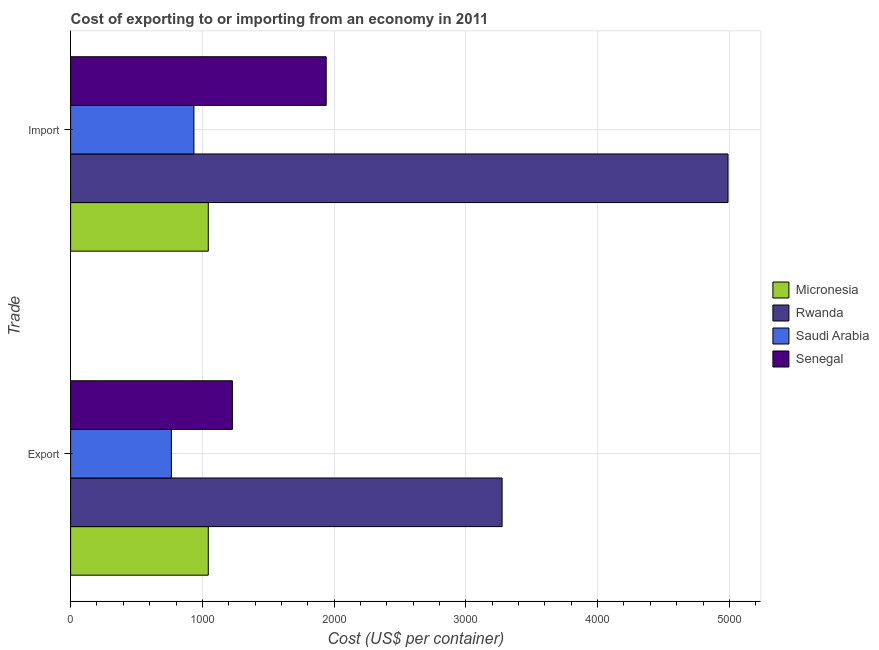How many bars are there on the 1st tick from the bottom?
Your answer should be very brief. 4. What is the label of the 2nd group of bars from the top?
Your answer should be very brief. Export. What is the export cost in Saudi Arabia?
Your response must be concise. 765. Across all countries, what is the maximum export cost?
Your answer should be compact. 3275. Across all countries, what is the minimum export cost?
Provide a short and direct response. 765. In which country was the export cost maximum?
Keep it short and to the point. Rwanda. In which country was the export cost minimum?
Provide a succinct answer. Saudi Arabia. What is the total import cost in the graph?
Make the answer very short. 8911. What is the difference between the import cost in Saudi Arabia and that in Micronesia?
Make the answer very short. -109. What is the difference between the export cost in Senegal and the import cost in Rwanda?
Your response must be concise. -3762. What is the average import cost per country?
Provide a succinct answer. 2227.75. What is the difference between the import cost and export cost in Saudi Arabia?
Offer a terse response. 171. What is the ratio of the export cost in Micronesia to that in Senegal?
Keep it short and to the point. 0.85. In how many countries, is the import cost greater than the average import cost taken over all countries?
Provide a short and direct response. 1. What does the 2nd bar from the top in Export represents?
Keep it short and to the point. Saudi Arabia. What does the 1st bar from the bottom in Export represents?
Ensure brevity in your answer.  Micronesia. Are all the bars in the graph horizontal?
Your response must be concise. Yes. How many countries are there in the graph?
Your answer should be very brief. 4. Are the values on the major ticks of X-axis written in scientific E-notation?
Make the answer very short. No. Does the graph contain any zero values?
Offer a terse response. No. How many legend labels are there?
Provide a succinct answer. 4. How are the legend labels stacked?
Keep it short and to the point. Vertical. What is the title of the graph?
Your response must be concise. Cost of exporting to or importing from an economy in 2011. What is the label or title of the X-axis?
Provide a short and direct response. Cost (US$ per container). What is the label or title of the Y-axis?
Provide a short and direct response. Trade. What is the Cost (US$ per container) of Micronesia in Export?
Offer a very short reply. 1045. What is the Cost (US$ per container) of Rwanda in Export?
Give a very brief answer. 3275. What is the Cost (US$ per container) of Saudi Arabia in Export?
Keep it short and to the point. 765. What is the Cost (US$ per container) of Senegal in Export?
Make the answer very short. 1228. What is the Cost (US$ per container) of Micronesia in Import?
Your response must be concise. 1045. What is the Cost (US$ per container) in Rwanda in Import?
Offer a terse response. 4990. What is the Cost (US$ per container) of Saudi Arabia in Import?
Provide a succinct answer. 936. What is the Cost (US$ per container) in Senegal in Import?
Give a very brief answer. 1940. Across all Trade, what is the maximum Cost (US$ per container) in Micronesia?
Make the answer very short. 1045. Across all Trade, what is the maximum Cost (US$ per container) in Rwanda?
Offer a very short reply. 4990. Across all Trade, what is the maximum Cost (US$ per container) of Saudi Arabia?
Your response must be concise. 936. Across all Trade, what is the maximum Cost (US$ per container) in Senegal?
Give a very brief answer. 1940. Across all Trade, what is the minimum Cost (US$ per container) in Micronesia?
Offer a very short reply. 1045. Across all Trade, what is the minimum Cost (US$ per container) in Rwanda?
Provide a succinct answer. 3275. Across all Trade, what is the minimum Cost (US$ per container) of Saudi Arabia?
Your answer should be compact. 765. Across all Trade, what is the minimum Cost (US$ per container) of Senegal?
Your answer should be very brief. 1228. What is the total Cost (US$ per container) of Micronesia in the graph?
Make the answer very short. 2090. What is the total Cost (US$ per container) in Rwanda in the graph?
Make the answer very short. 8265. What is the total Cost (US$ per container) of Saudi Arabia in the graph?
Offer a terse response. 1701. What is the total Cost (US$ per container) of Senegal in the graph?
Provide a succinct answer. 3168. What is the difference between the Cost (US$ per container) in Rwanda in Export and that in Import?
Offer a very short reply. -1715. What is the difference between the Cost (US$ per container) of Saudi Arabia in Export and that in Import?
Offer a terse response. -171. What is the difference between the Cost (US$ per container) in Senegal in Export and that in Import?
Offer a very short reply. -712. What is the difference between the Cost (US$ per container) of Micronesia in Export and the Cost (US$ per container) of Rwanda in Import?
Provide a succinct answer. -3945. What is the difference between the Cost (US$ per container) of Micronesia in Export and the Cost (US$ per container) of Saudi Arabia in Import?
Ensure brevity in your answer.  109. What is the difference between the Cost (US$ per container) of Micronesia in Export and the Cost (US$ per container) of Senegal in Import?
Offer a terse response. -895. What is the difference between the Cost (US$ per container) of Rwanda in Export and the Cost (US$ per container) of Saudi Arabia in Import?
Give a very brief answer. 2339. What is the difference between the Cost (US$ per container) in Rwanda in Export and the Cost (US$ per container) in Senegal in Import?
Offer a terse response. 1335. What is the difference between the Cost (US$ per container) of Saudi Arabia in Export and the Cost (US$ per container) of Senegal in Import?
Offer a very short reply. -1175. What is the average Cost (US$ per container) of Micronesia per Trade?
Give a very brief answer. 1045. What is the average Cost (US$ per container) in Rwanda per Trade?
Provide a succinct answer. 4132.5. What is the average Cost (US$ per container) of Saudi Arabia per Trade?
Your answer should be compact. 850.5. What is the average Cost (US$ per container) of Senegal per Trade?
Provide a short and direct response. 1584. What is the difference between the Cost (US$ per container) of Micronesia and Cost (US$ per container) of Rwanda in Export?
Offer a very short reply. -2230. What is the difference between the Cost (US$ per container) of Micronesia and Cost (US$ per container) of Saudi Arabia in Export?
Make the answer very short. 280. What is the difference between the Cost (US$ per container) in Micronesia and Cost (US$ per container) in Senegal in Export?
Provide a short and direct response. -183. What is the difference between the Cost (US$ per container) in Rwanda and Cost (US$ per container) in Saudi Arabia in Export?
Make the answer very short. 2510. What is the difference between the Cost (US$ per container) of Rwanda and Cost (US$ per container) of Senegal in Export?
Your answer should be compact. 2047. What is the difference between the Cost (US$ per container) of Saudi Arabia and Cost (US$ per container) of Senegal in Export?
Give a very brief answer. -463. What is the difference between the Cost (US$ per container) of Micronesia and Cost (US$ per container) of Rwanda in Import?
Your answer should be compact. -3945. What is the difference between the Cost (US$ per container) of Micronesia and Cost (US$ per container) of Saudi Arabia in Import?
Give a very brief answer. 109. What is the difference between the Cost (US$ per container) of Micronesia and Cost (US$ per container) of Senegal in Import?
Provide a short and direct response. -895. What is the difference between the Cost (US$ per container) of Rwanda and Cost (US$ per container) of Saudi Arabia in Import?
Provide a succinct answer. 4054. What is the difference between the Cost (US$ per container) of Rwanda and Cost (US$ per container) of Senegal in Import?
Your answer should be compact. 3050. What is the difference between the Cost (US$ per container) in Saudi Arabia and Cost (US$ per container) in Senegal in Import?
Your answer should be very brief. -1004. What is the ratio of the Cost (US$ per container) of Micronesia in Export to that in Import?
Your answer should be compact. 1. What is the ratio of the Cost (US$ per container) in Rwanda in Export to that in Import?
Provide a succinct answer. 0.66. What is the ratio of the Cost (US$ per container) of Saudi Arabia in Export to that in Import?
Your answer should be very brief. 0.82. What is the ratio of the Cost (US$ per container) of Senegal in Export to that in Import?
Ensure brevity in your answer.  0.63. What is the difference between the highest and the second highest Cost (US$ per container) in Rwanda?
Offer a terse response. 1715. What is the difference between the highest and the second highest Cost (US$ per container) in Saudi Arabia?
Your answer should be compact. 171. What is the difference between the highest and the second highest Cost (US$ per container) in Senegal?
Provide a short and direct response. 712. What is the difference between the highest and the lowest Cost (US$ per container) of Micronesia?
Give a very brief answer. 0. What is the difference between the highest and the lowest Cost (US$ per container) of Rwanda?
Offer a very short reply. 1715. What is the difference between the highest and the lowest Cost (US$ per container) in Saudi Arabia?
Your response must be concise. 171. What is the difference between the highest and the lowest Cost (US$ per container) of Senegal?
Keep it short and to the point. 712. 